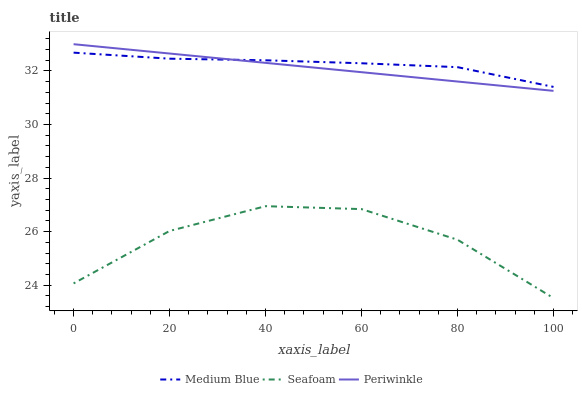Does Seafoam have the minimum area under the curve?
Answer yes or no. Yes. Does Medium Blue have the maximum area under the curve?
Answer yes or no. Yes. Does Medium Blue have the minimum area under the curve?
Answer yes or no. No. Does Seafoam have the maximum area under the curve?
Answer yes or no. No. Is Periwinkle the smoothest?
Answer yes or no. Yes. Is Seafoam the roughest?
Answer yes or no. Yes. Is Medium Blue the smoothest?
Answer yes or no. No. Is Medium Blue the roughest?
Answer yes or no. No. Does Medium Blue have the lowest value?
Answer yes or no. No. Does Periwinkle have the highest value?
Answer yes or no. Yes. Does Medium Blue have the highest value?
Answer yes or no. No. Is Seafoam less than Periwinkle?
Answer yes or no. Yes. Is Periwinkle greater than Seafoam?
Answer yes or no. Yes. Does Medium Blue intersect Periwinkle?
Answer yes or no. Yes. Is Medium Blue less than Periwinkle?
Answer yes or no. No. Is Medium Blue greater than Periwinkle?
Answer yes or no. No. Does Seafoam intersect Periwinkle?
Answer yes or no. No. 